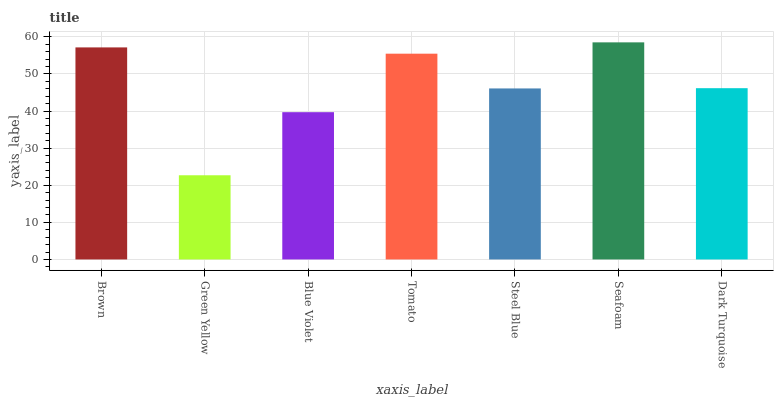Is Green Yellow the minimum?
Answer yes or no. Yes. Is Seafoam the maximum?
Answer yes or no. Yes. Is Blue Violet the minimum?
Answer yes or no. No. Is Blue Violet the maximum?
Answer yes or no. No. Is Blue Violet greater than Green Yellow?
Answer yes or no. Yes. Is Green Yellow less than Blue Violet?
Answer yes or no. Yes. Is Green Yellow greater than Blue Violet?
Answer yes or no. No. Is Blue Violet less than Green Yellow?
Answer yes or no. No. Is Dark Turquoise the high median?
Answer yes or no. Yes. Is Dark Turquoise the low median?
Answer yes or no. Yes. Is Tomato the high median?
Answer yes or no. No. Is Seafoam the low median?
Answer yes or no. No. 